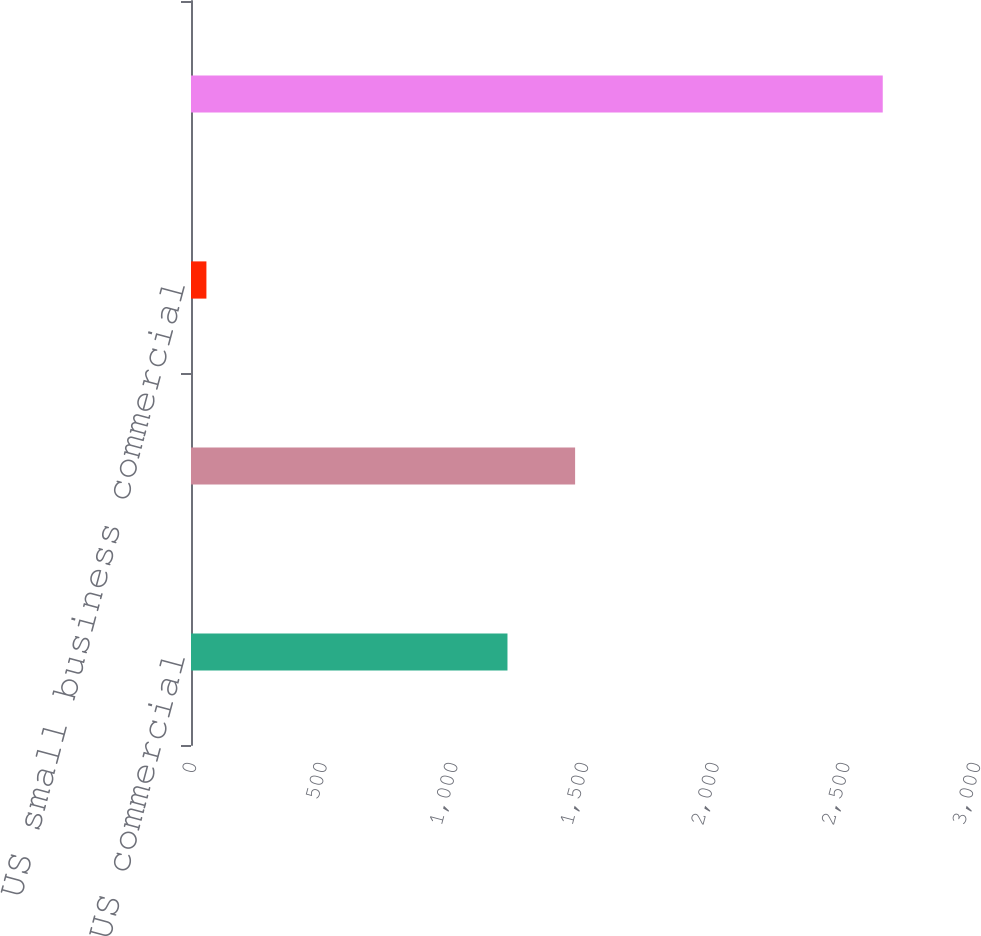Convert chart. <chart><loc_0><loc_0><loc_500><loc_500><bar_chart><fcel>US commercial<fcel>Commercial real estate<fcel>US small business commercial<fcel>Total<nl><fcel>1211<fcel>1469.8<fcel>59<fcel>2647<nl></chart> 